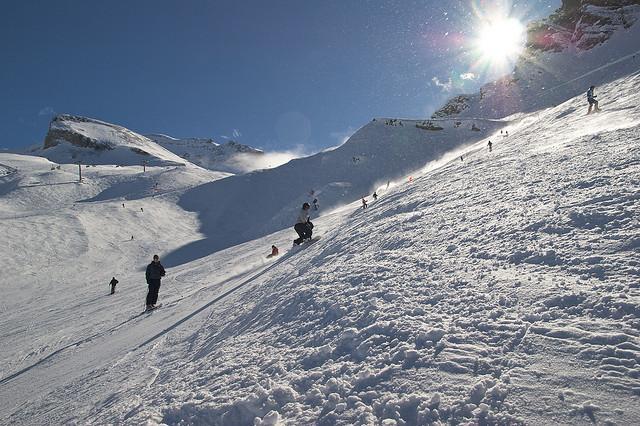How many kites are flying?
Give a very brief answer. 0. 